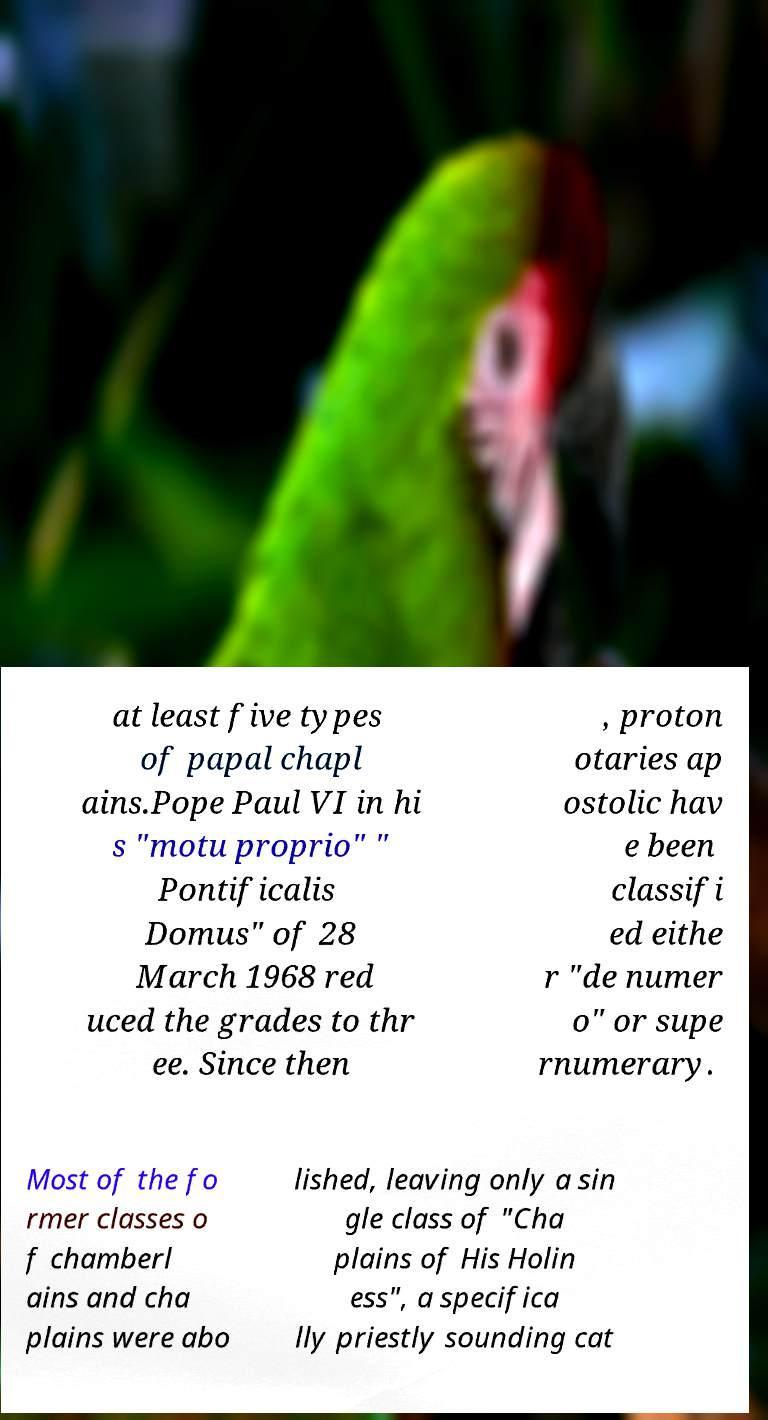For documentation purposes, I need the text within this image transcribed. Could you provide that? at least five types of papal chapl ains.Pope Paul VI in hi s "motu proprio" " Pontificalis Domus" of 28 March 1968 red uced the grades to thr ee. Since then , proton otaries ap ostolic hav e been classifi ed eithe r "de numer o" or supe rnumerary. Most of the fo rmer classes o f chamberl ains and cha plains were abo lished, leaving only a sin gle class of "Cha plains of His Holin ess", a specifica lly priestly sounding cat 